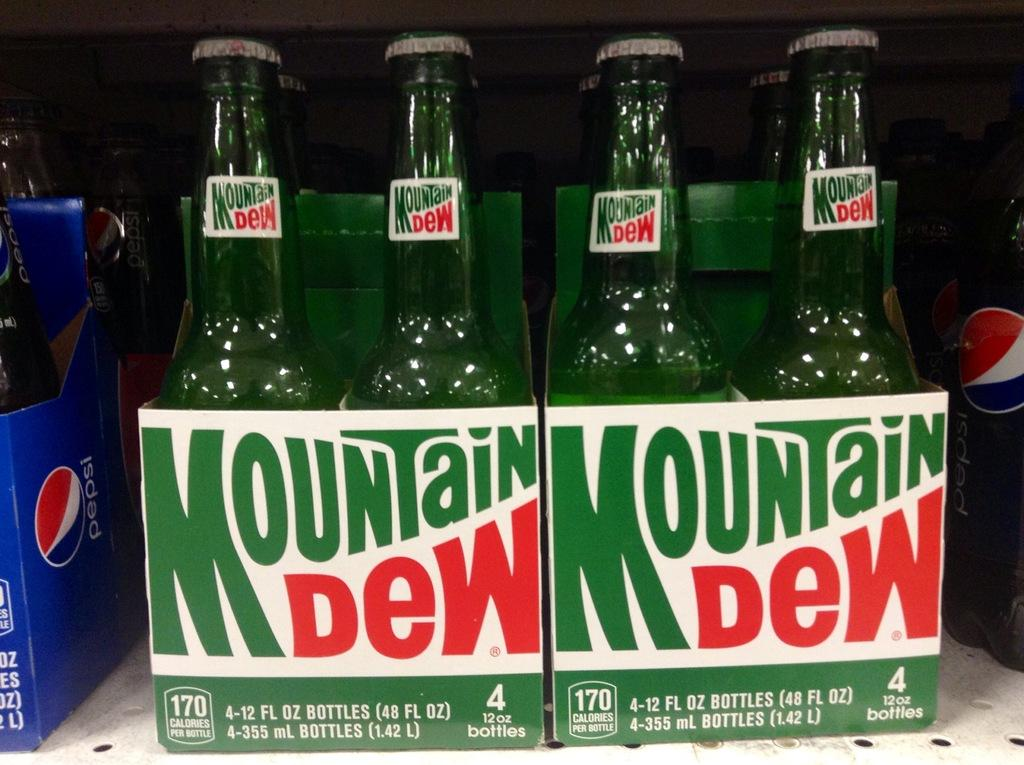Provide a one-sentence caption for the provided image. Two 4 packs of bottles of Mountain Dew. 